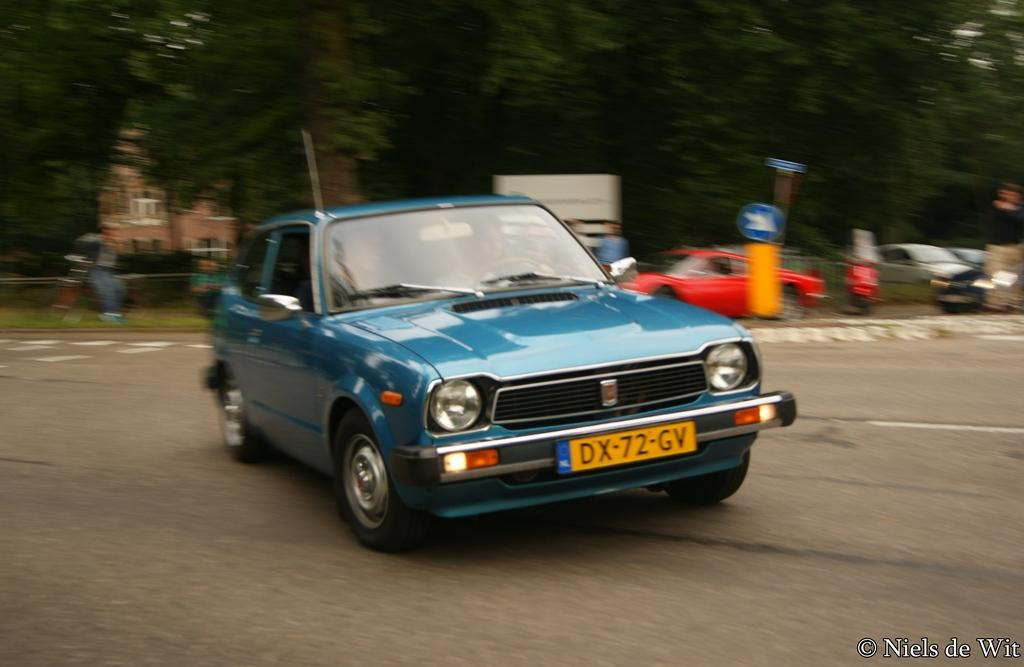What can be seen on the road in the image? There are vehicles on the road in the image. What is present near the road in the image? There is a signboard in the image. What type of natural elements are visible in the image? There are trees in the image. What type of structure is present in the image? There is a house in the image. What can be read or deciphered in the image? There is text visible on the image. How would you describe the background of the image? The background of the image is blurred. Can you tell me how many people are walking on the sidewalk in the image? There is no sidewalk present in the image, as it primarily features vehicles on the road, a signboard, trees, a house, text, and a blurred background. 